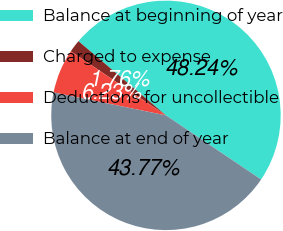Convert chart. <chart><loc_0><loc_0><loc_500><loc_500><pie_chart><fcel>Balance at beginning of year<fcel>Charged to expense<fcel>Deductions for uncollectible<fcel>Balance at end of year<nl><fcel>48.24%<fcel>1.76%<fcel>6.23%<fcel>43.77%<nl></chart> 